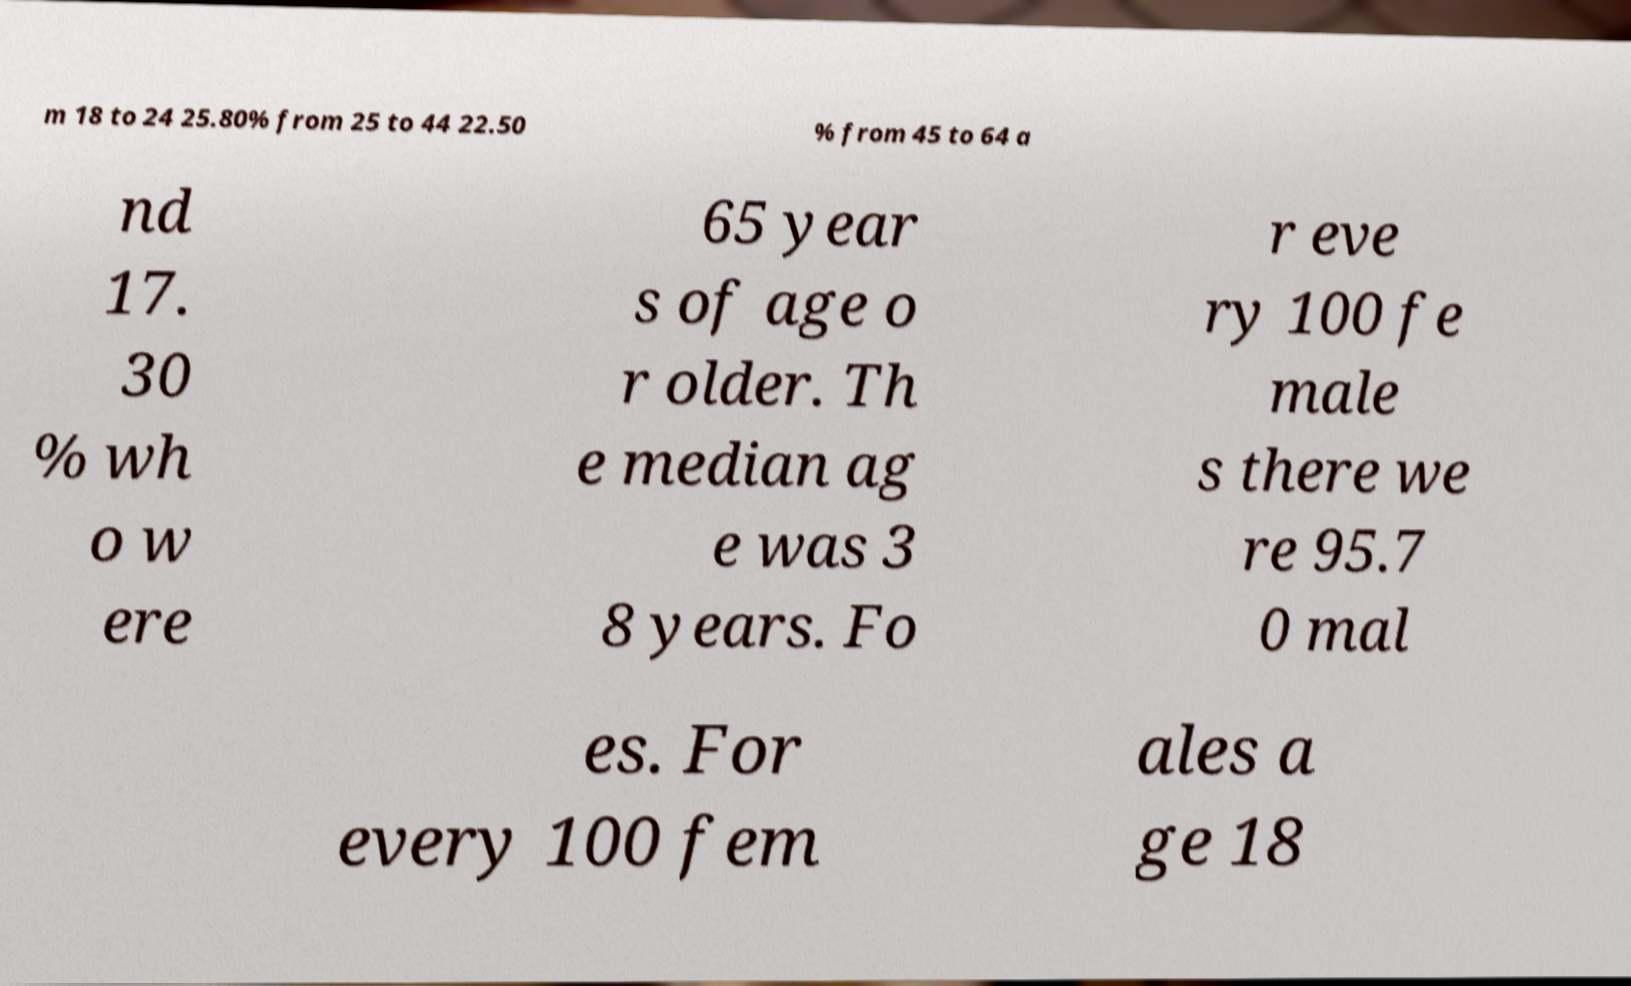Please read and relay the text visible in this image. What does it say? m 18 to 24 25.80% from 25 to 44 22.50 % from 45 to 64 a nd 17. 30 % wh o w ere 65 year s of age o r older. Th e median ag e was 3 8 years. Fo r eve ry 100 fe male s there we re 95.7 0 mal es. For every 100 fem ales a ge 18 